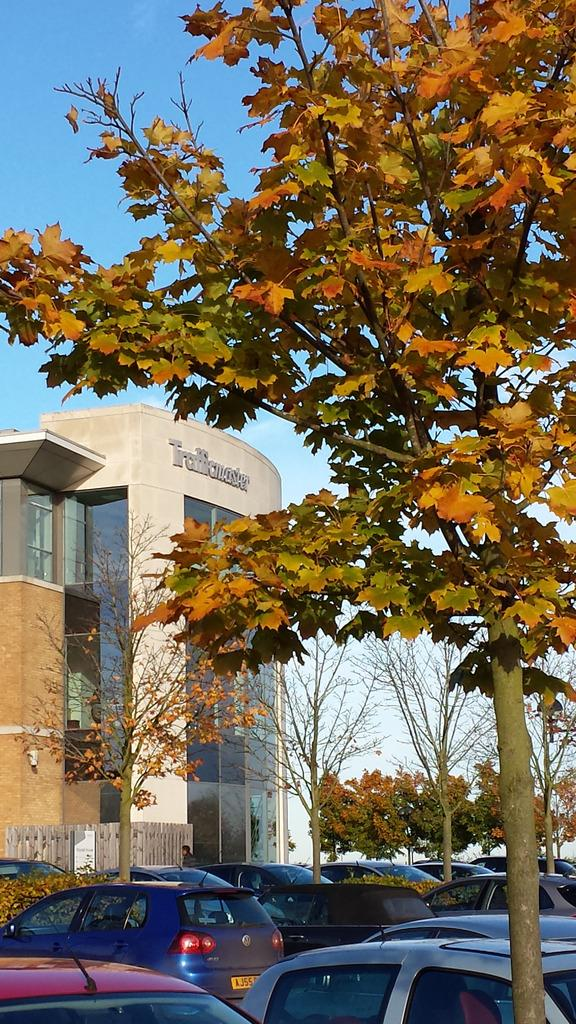What type of structure is present in the image? There is a building in the image. What is located near the building? There is a fence in the image. What can be seen on the ground in front of the building? Vehicles are parked on the ground in front of the building. What type of natural elements are visible in the image? There are trees visible in the image. What is visible above the trees and vehicles in the image? The sky is visible in the image. What year is the order for the building's construction placed? There is no information about the order or the year of construction in the image. 